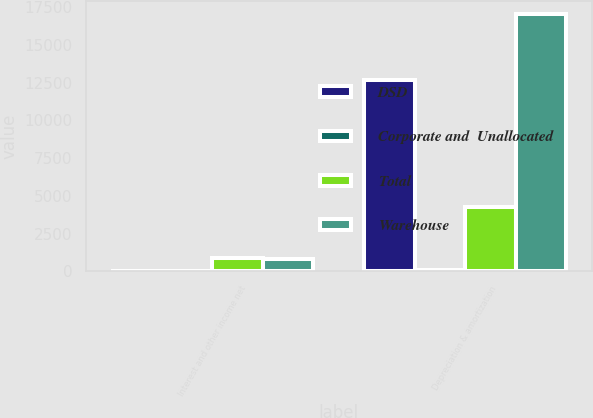Convert chart. <chart><loc_0><loc_0><loc_500><loc_500><stacked_bar_chart><ecel><fcel>Interest and other income net<fcel>Depreciation & amortization<nl><fcel>DSD<fcel>12<fcel>12684<nl><fcel>Corporate and  Unallocated<fcel>1<fcel>87<nl><fcel>Total<fcel>860<fcel>4261<nl><fcel>Warehouse<fcel>847<fcel>17032<nl></chart> 